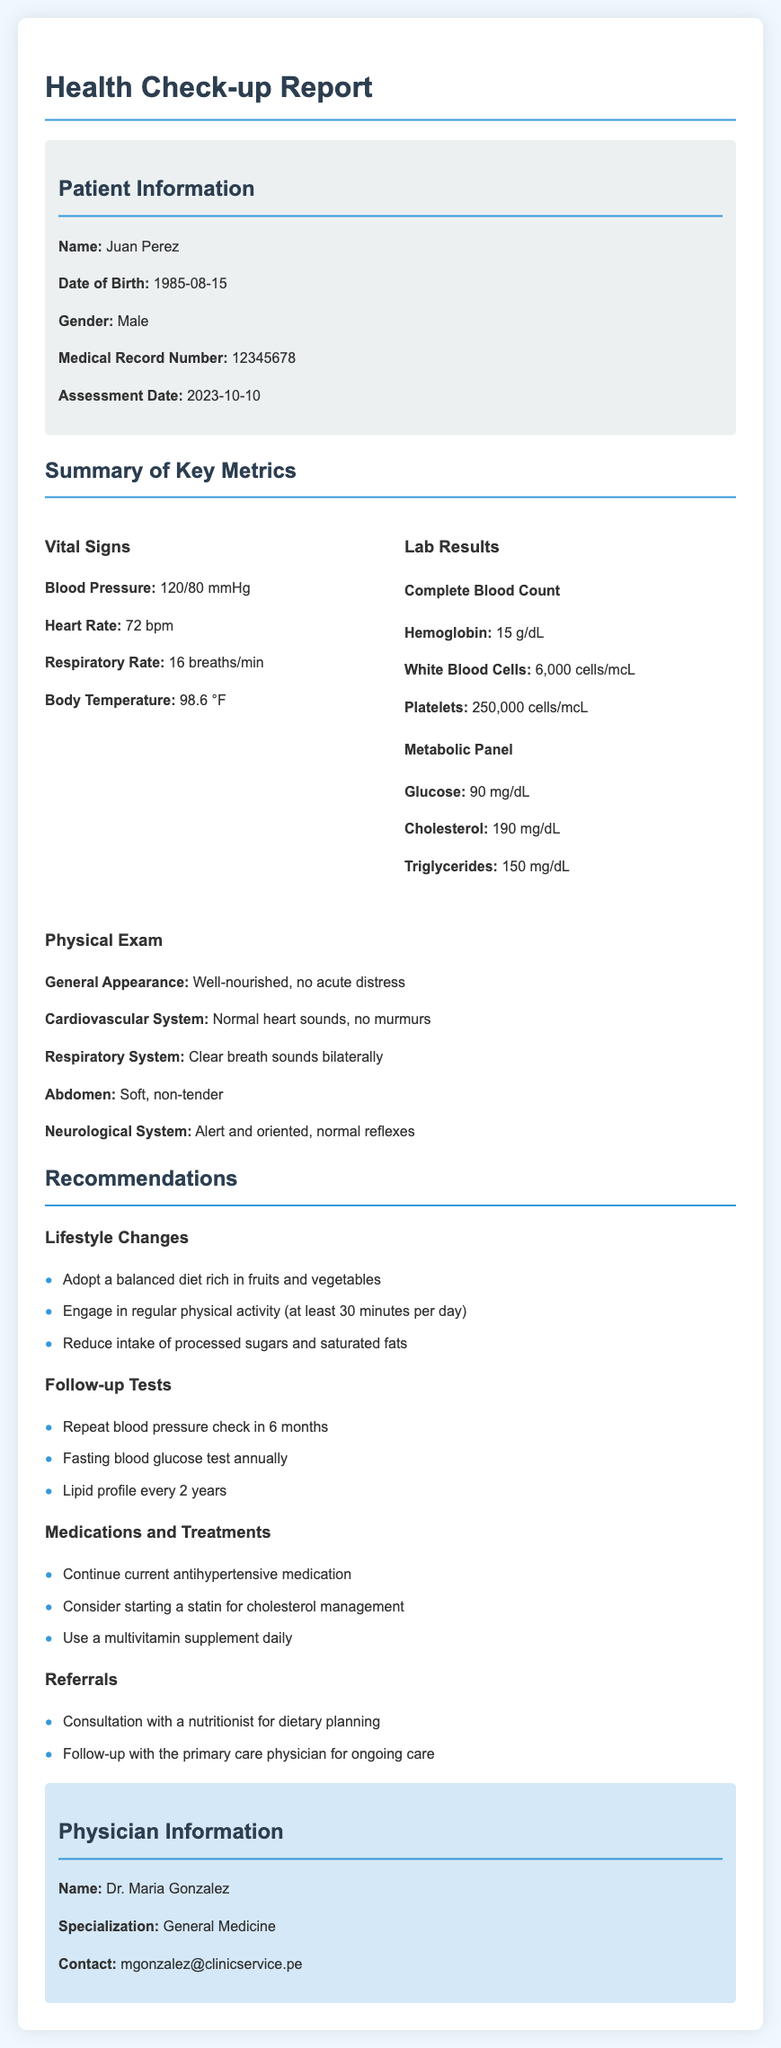What is the name of the patient? The patient's name is clearly stated in the patient information section.
Answer: Juan Perez What is the date of assessment? The assessment date is provided in the patient information section.
Answer: 2023-10-10 What is the blood pressure reading? The blood pressure reading is mentioned under vital signs in the summary of key metrics.
Answer: 120/80 mmHg What is the cholesterol level reported? The cholesterol level is included in the lab results section under the metabolic panel.
Answer: 190 mg/dL How many minutes of physical activity are recommended daily? The recommendations section specifies the amount of physical activity suggested.
Answer: 30 minutes Who is the physician listed in the report? The physician's name is provided at the end of the document.
Answer: Dr. Maria Gonzalez What type of medication is suggested for cholesterol management? The recommendations include a specific treatment option for cholesterol.
Answer: Statin What is the recommended follow-up for blood pressure? The recommendations detail the follow-up actions required for blood pressure.
Answer: Repeat blood pressure check in 6 months What specialty does the physician hold? The physician's area of expertise is specified in the document.
Answer: General Medicine 